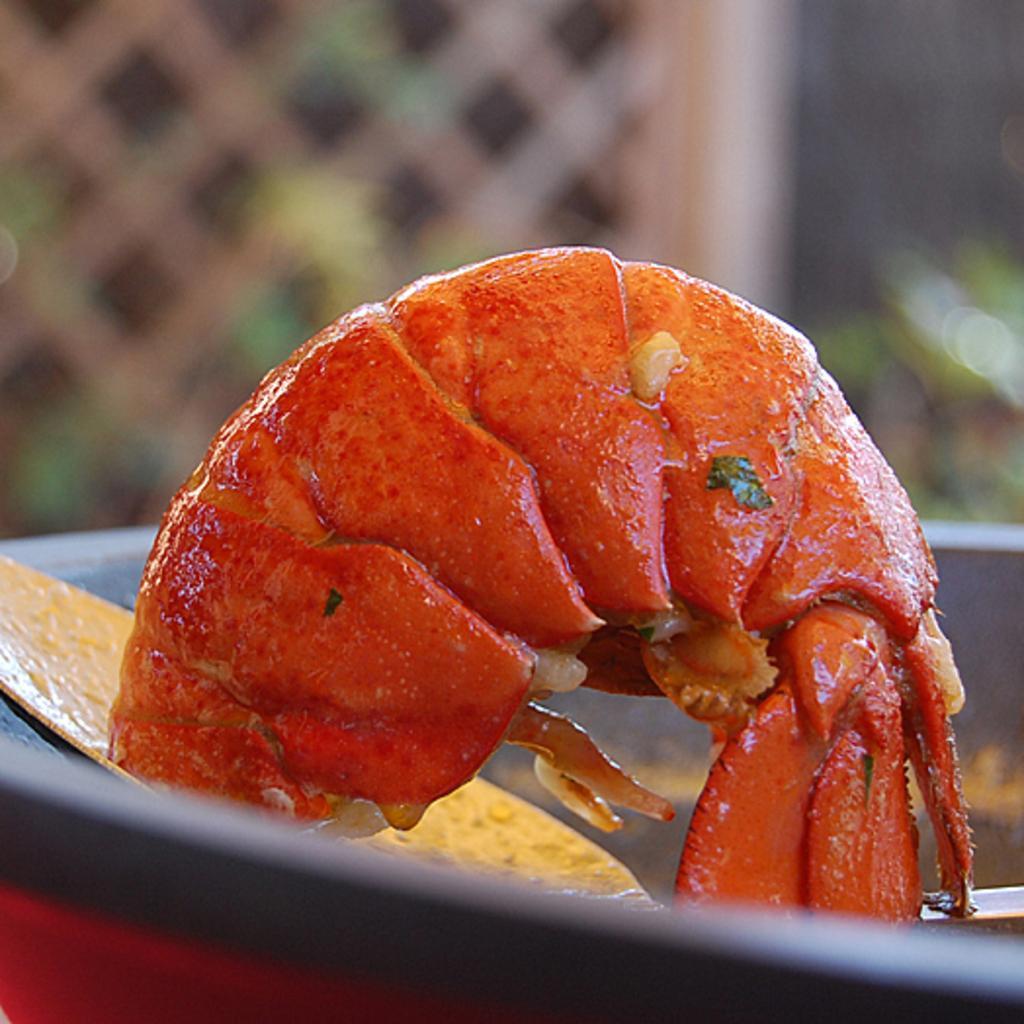How would you summarize this image in a sentence or two? In this picture we can see a shrimp in an object. Behind the shrimp, there is a blurred background. 